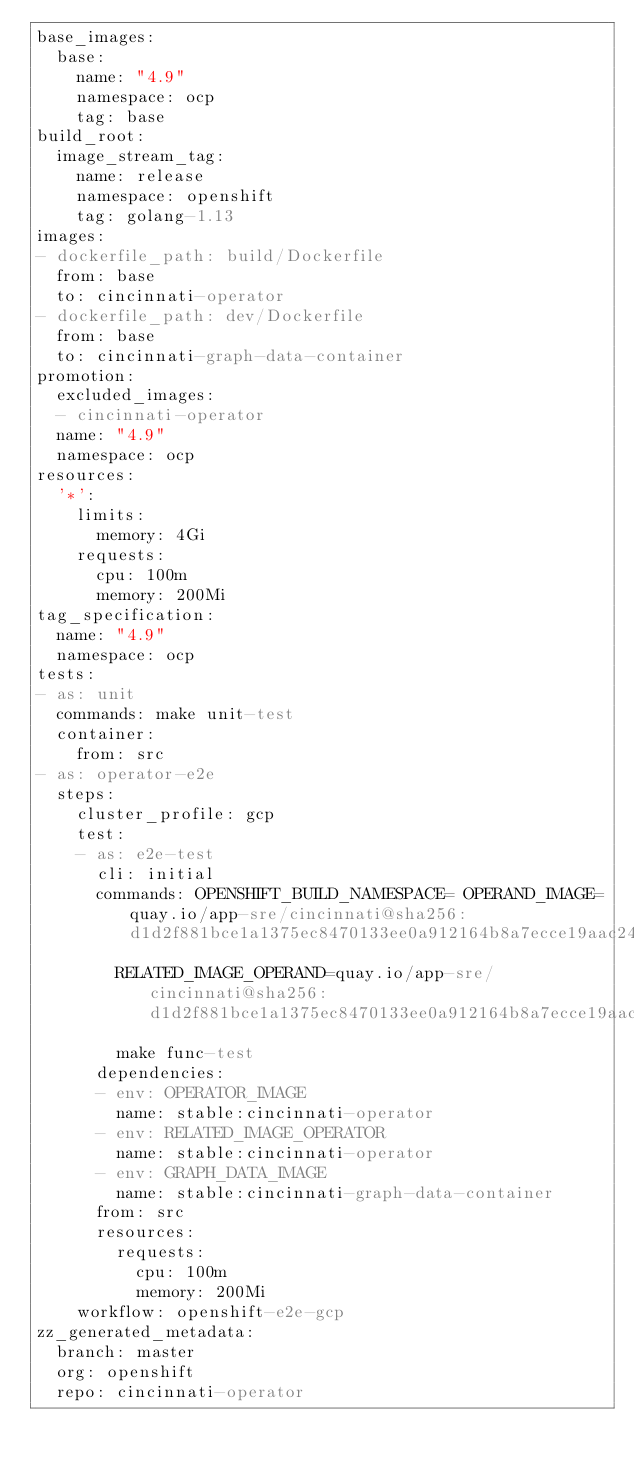Convert code to text. <code><loc_0><loc_0><loc_500><loc_500><_YAML_>base_images:
  base:
    name: "4.9"
    namespace: ocp
    tag: base
build_root:
  image_stream_tag:
    name: release
    namespace: openshift
    tag: golang-1.13
images:
- dockerfile_path: build/Dockerfile
  from: base
  to: cincinnati-operator
- dockerfile_path: dev/Dockerfile
  from: base
  to: cincinnati-graph-data-container
promotion:
  excluded_images:
  - cincinnati-operator
  name: "4.9"
  namespace: ocp
resources:
  '*':
    limits:
      memory: 4Gi
    requests:
      cpu: 100m
      memory: 200Mi
tag_specification:
  name: "4.9"
  namespace: ocp
tests:
- as: unit
  commands: make unit-test
  container:
    from: src
- as: operator-e2e
  steps:
    cluster_profile: gcp
    test:
    - as: e2e-test
      cli: initial
      commands: OPENSHIFT_BUILD_NAMESPACE= OPERAND_IMAGE=quay.io/app-sre/cincinnati@sha256:d1d2f881bce1a1375ec8470133ee0a912164b8a7ecce19aac24d24e623aef59b
        RELATED_IMAGE_OPERAND=quay.io/app-sre/cincinnati@sha256:d1d2f881bce1a1375ec8470133ee0a912164b8a7ecce19aac24d24e623aef59b
        make func-test
      dependencies:
      - env: OPERATOR_IMAGE
        name: stable:cincinnati-operator
      - env: RELATED_IMAGE_OPERATOR
        name: stable:cincinnati-operator
      - env: GRAPH_DATA_IMAGE
        name: stable:cincinnati-graph-data-container
      from: src
      resources:
        requests:
          cpu: 100m
          memory: 200Mi
    workflow: openshift-e2e-gcp
zz_generated_metadata:
  branch: master
  org: openshift
  repo: cincinnati-operator
</code> 